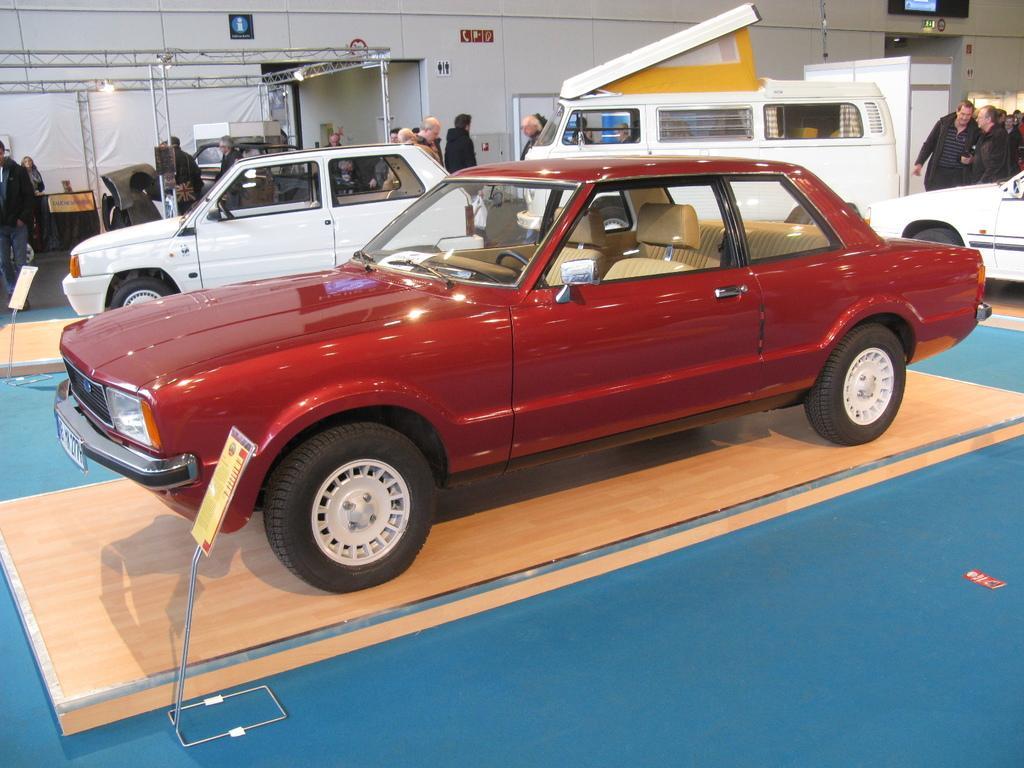Please provide a concise description of this image. In this image I can see number of vehicles and number of people. In the background I can see a white wall. 